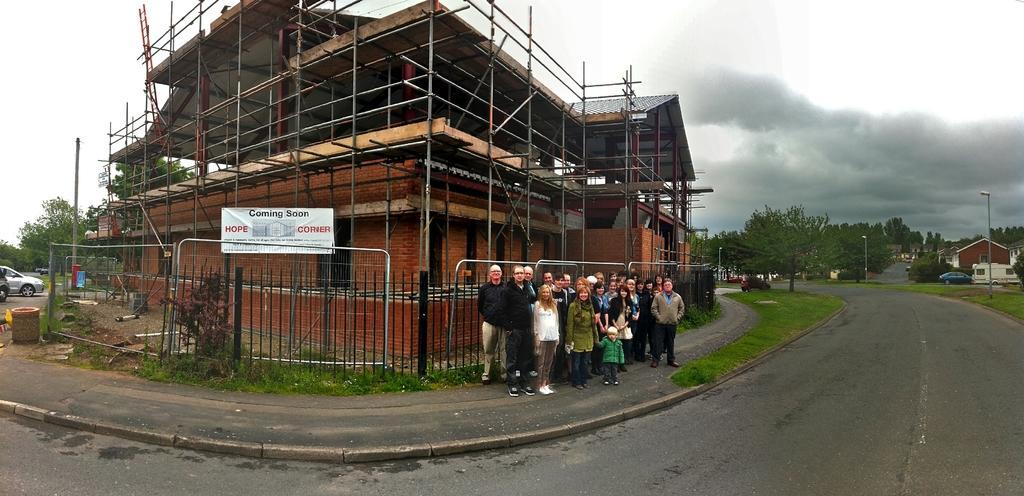Can you describe this image briefly? In this image we can see the buildings and houses and trees and also light poles. We can also see the fence, ladder and a banner. Image also consists of some vehicles on the road. We can also see few people standing. At the top there is a cloudy sky. 